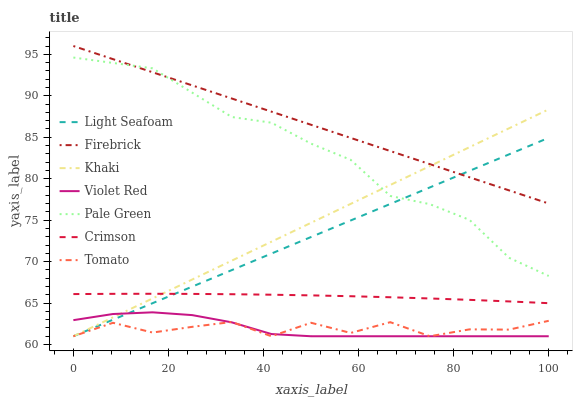Does Violet Red have the minimum area under the curve?
Answer yes or no. Yes. Does Firebrick have the maximum area under the curve?
Answer yes or no. Yes. Does Khaki have the minimum area under the curve?
Answer yes or no. No. Does Khaki have the maximum area under the curve?
Answer yes or no. No. Is Light Seafoam the smoothest?
Answer yes or no. Yes. Is Tomato the roughest?
Answer yes or no. Yes. Is Violet Red the smoothest?
Answer yes or no. No. Is Violet Red the roughest?
Answer yes or no. No. Does Tomato have the lowest value?
Answer yes or no. Yes. Does Firebrick have the lowest value?
Answer yes or no. No. Does Firebrick have the highest value?
Answer yes or no. Yes. Does Violet Red have the highest value?
Answer yes or no. No. Is Tomato less than Crimson?
Answer yes or no. Yes. Is Crimson greater than Violet Red?
Answer yes or no. Yes. Does Light Seafoam intersect Firebrick?
Answer yes or no. Yes. Is Light Seafoam less than Firebrick?
Answer yes or no. No. Is Light Seafoam greater than Firebrick?
Answer yes or no. No. Does Tomato intersect Crimson?
Answer yes or no. No. 